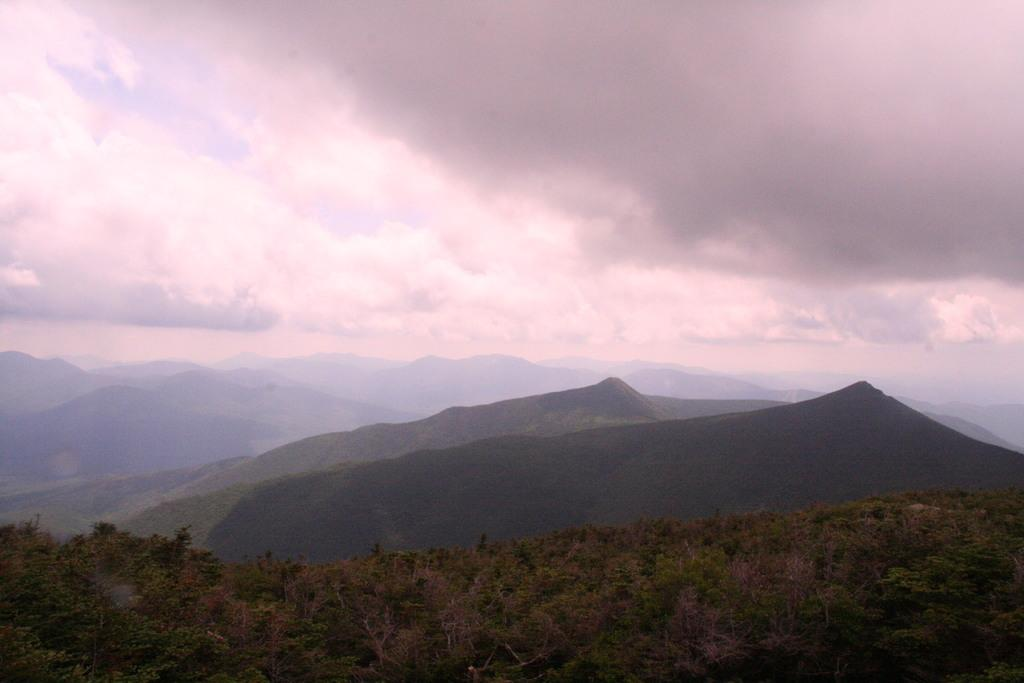What type of natural features can be seen in the image? There are trees and mountains in the image. What is the condition of the sky in the image? The sky is cloudy in the image. What type of story is being told by the coal in the image? There is no coal present in the image, so no story can be told by it. How many stitches are visible on the trees in the image? There are no stitches on the trees in the image; they are natural, living organisms. 